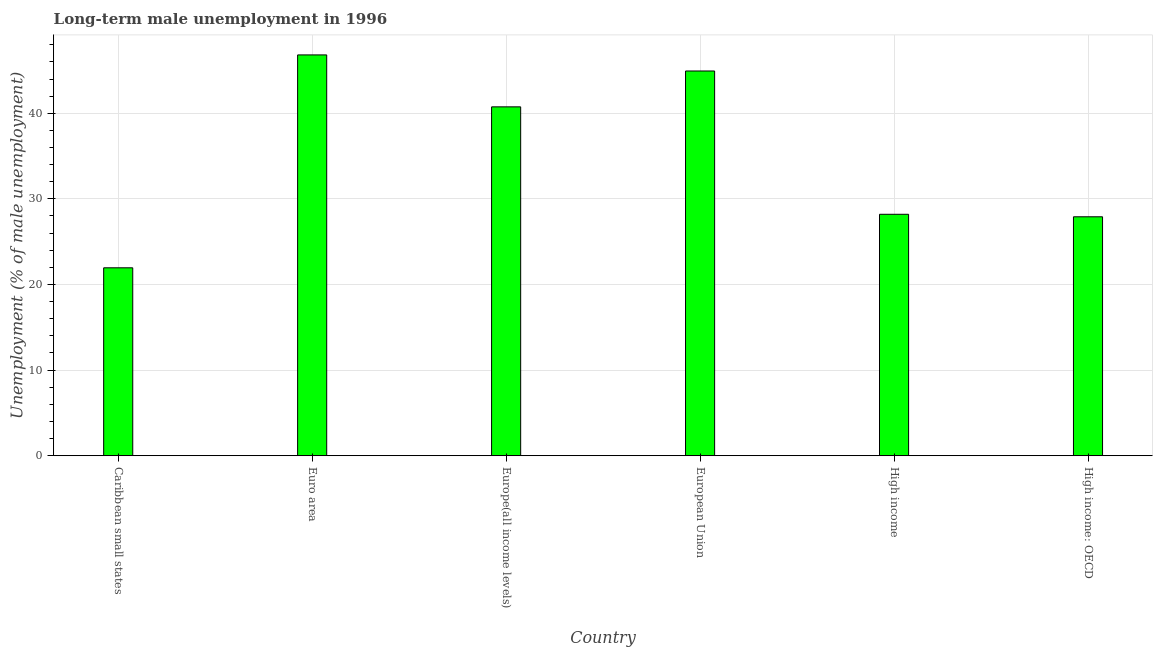Does the graph contain any zero values?
Your response must be concise. No. Does the graph contain grids?
Make the answer very short. Yes. What is the title of the graph?
Your answer should be compact. Long-term male unemployment in 1996. What is the label or title of the Y-axis?
Give a very brief answer. Unemployment (% of male unemployment). What is the long-term male unemployment in High income: OECD?
Your response must be concise. 27.91. Across all countries, what is the maximum long-term male unemployment?
Your answer should be very brief. 46.81. Across all countries, what is the minimum long-term male unemployment?
Your answer should be compact. 21.95. In which country was the long-term male unemployment maximum?
Give a very brief answer. Euro area. In which country was the long-term male unemployment minimum?
Give a very brief answer. Caribbean small states. What is the sum of the long-term male unemployment?
Give a very brief answer. 210.55. What is the difference between the long-term male unemployment in Caribbean small states and High income: OECD?
Your response must be concise. -5.96. What is the average long-term male unemployment per country?
Provide a succinct answer. 35.09. What is the median long-term male unemployment?
Keep it short and to the point. 34.47. In how many countries, is the long-term male unemployment greater than 22 %?
Give a very brief answer. 5. What is the ratio of the long-term male unemployment in European Union to that in High income: OECD?
Provide a succinct answer. 1.61. Is the long-term male unemployment in European Union less than that in High income?
Provide a short and direct response. No. What is the difference between the highest and the second highest long-term male unemployment?
Offer a terse response. 1.88. What is the difference between the highest and the lowest long-term male unemployment?
Give a very brief answer. 24.87. In how many countries, is the long-term male unemployment greater than the average long-term male unemployment taken over all countries?
Give a very brief answer. 3. Are all the bars in the graph horizontal?
Provide a succinct answer. No. How many countries are there in the graph?
Give a very brief answer. 6. Are the values on the major ticks of Y-axis written in scientific E-notation?
Your answer should be compact. No. What is the Unemployment (% of male unemployment) of Caribbean small states?
Your answer should be very brief. 21.95. What is the Unemployment (% of male unemployment) in Euro area?
Provide a succinct answer. 46.81. What is the Unemployment (% of male unemployment) in Europe(all income levels)?
Keep it short and to the point. 40.75. What is the Unemployment (% of male unemployment) in European Union?
Make the answer very short. 44.94. What is the Unemployment (% of male unemployment) of High income?
Provide a succinct answer. 28.2. What is the Unemployment (% of male unemployment) in High income: OECD?
Provide a short and direct response. 27.91. What is the difference between the Unemployment (% of male unemployment) in Caribbean small states and Euro area?
Provide a succinct answer. -24.87. What is the difference between the Unemployment (% of male unemployment) in Caribbean small states and Europe(all income levels)?
Offer a very short reply. -18.8. What is the difference between the Unemployment (% of male unemployment) in Caribbean small states and European Union?
Make the answer very short. -22.99. What is the difference between the Unemployment (% of male unemployment) in Caribbean small states and High income?
Provide a short and direct response. -6.25. What is the difference between the Unemployment (% of male unemployment) in Caribbean small states and High income: OECD?
Your answer should be very brief. -5.96. What is the difference between the Unemployment (% of male unemployment) in Euro area and Europe(all income levels)?
Your answer should be very brief. 6.07. What is the difference between the Unemployment (% of male unemployment) in Euro area and European Union?
Give a very brief answer. 1.88. What is the difference between the Unemployment (% of male unemployment) in Euro area and High income?
Offer a terse response. 18.62. What is the difference between the Unemployment (% of male unemployment) in Euro area and High income: OECD?
Offer a terse response. 18.91. What is the difference between the Unemployment (% of male unemployment) in Europe(all income levels) and European Union?
Your answer should be very brief. -4.19. What is the difference between the Unemployment (% of male unemployment) in Europe(all income levels) and High income?
Provide a short and direct response. 12.55. What is the difference between the Unemployment (% of male unemployment) in Europe(all income levels) and High income: OECD?
Provide a short and direct response. 12.84. What is the difference between the Unemployment (% of male unemployment) in European Union and High income?
Offer a very short reply. 16.74. What is the difference between the Unemployment (% of male unemployment) in European Union and High income: OECD?
Make the answer very short. 17.03. What is the difference between the Unemployment (% of male unemployment) in High income and High income: OECD?
Offer a terse response. 0.29. What is the ratio of the Unemployment (% of male unemployment) in Caribbean small states to that in Euro area?
Keep it short and to the point. 0.47. What is the ratio of the Unemployment (% of male unemployment) in Caribbean small states to that in Europe(all income levels)?
Give a very brief answer. 0.54. What is the ratio of the Unemployment (% of male unemployment) in Caribbean small states to that in European Union?
Your answer should be very brief. 0.49. What is the ratio of the Unemployment (% of male unemployment) in Caribbean small states to that in High income?
Offer a terse response. 0.78. What is the ratio of the Unemployment (% of male unemployment) in Caribbean small states to that in High income: OECD?
Keep it short and to the point. 0.79. What is the ratio of the Unemployment (% of male unemployment) in Euro area to that in Europe(all income levels)?
Your answer should be compact. 1.15. What is the ratio of the Unemployment (% of male unemployment) in Euro area to that in European Union?
Offer a terse response. 1.04. What is the ratio of the Unemployment (% of male unemployment) in Euro area to that in High income?
Keep it short and to the point. 1.66. What is the ratio of the Unemployment (% of male unemployment) in Euro area to that in High income: OECD?
Give a very brief answer. 1.68. What is the ratio of the Unemployment (% of male unemployment) in Europe(all income levels) to that in European Union?
Make the answer very short. 0.91. What is the ratio of the Unemployment (% of male unemployment) in Europe(all income levels) to that in High income?
Make the answer very short. 1.45. What is the ratio of the Unemployment (% of male unemployment) in Europe(all income levels) to that in High income: OECD?
Make the answer very short. 1.46. What is the ratio of the Unemployment (% of male unemployment) in European Union to that in High income?
Give a very brief answer. 1.59. What is the ratio of the Unemployment (% of male unemployment) in European Union to that in High income: OECD?
Give a very brief answer. 1.61. 